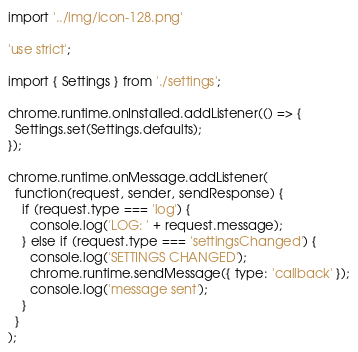<code> <loc_0><loc_0><loc_500><loc_500><_JavaScript_>import '../img/icon-128.png'

'use strict';

import { Settings } from './settings';

chrome.runtime.onInstalled.addListener(() => {
  Settings.set(Settings.defaults);
});

chrome.runtime.onMessage.addListener(
  function(request, sender, sendResponse) {
    if (request.type === 'log') {
      console.log('LOG: ' + request.message);
    } else if (request.type === 'settingsChanged') {
      console.log('SETTINGS CHANGED');
      chrome.runtime.sendMessage({ type: 'callback' });
      console.log('message sent');
    }
  }
);
</code> 